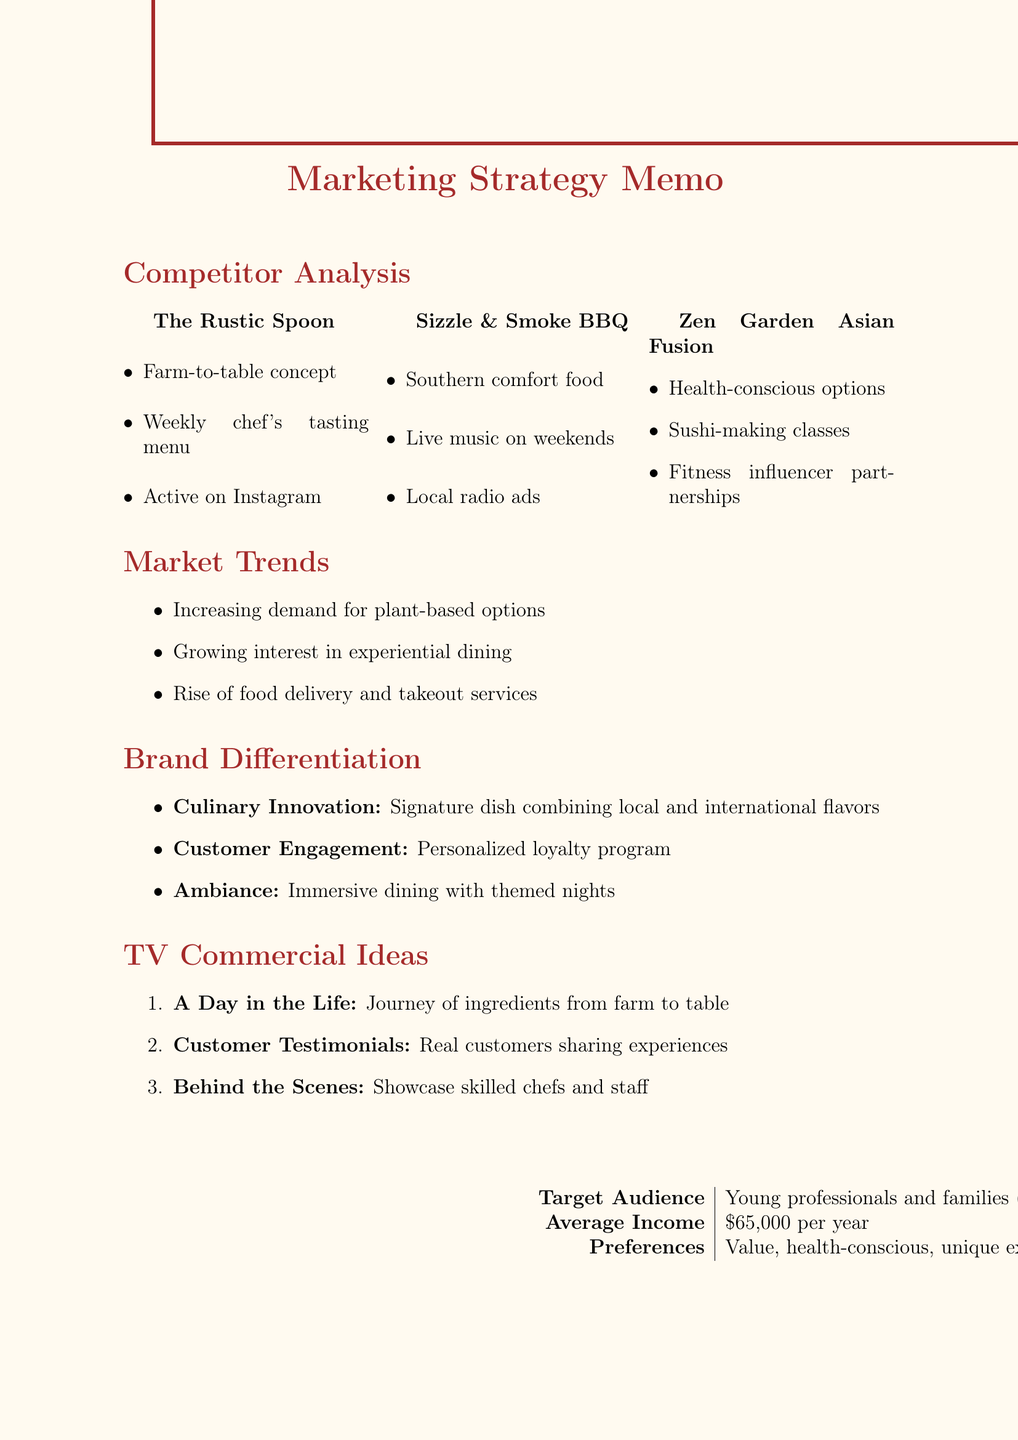What is the unique selling point of The Rustic Spoon? The unique selling point of The Rustic Spoon is highlighted in the document, which states it features a weekly chef's tasting menu showcasing seasonal specialties.
Answer: Weekly chef's tasting menu What marketing strategy does Sizzle & Smoke BBQ use? The marketing strategy of Sizzle & Smoke BBQ is described as Southern comfort food with a modern twist in the memo.
Answer: Southern comfort food with a modern twist Which restaurant offers interactive sushi-making classes? The document indicates that Zen Garden Asian Fusion offers interactive sushi-making classes for customers.
Answer: Zen Garden Asian Fusion What is one of the market trends mentioned? The document lists several market trends, one among them being increasing demand for plant-based menu options.
Answer: Increasing demand for plant-based menu options What aspect of brand differentiation focuses on customer loyalty? The aspect of brand differentiation that focuses on customer loyalty is described as implementing a loyalty program with personalized rewards based on dining preferences.
Answer: Customer Engagement How many TV commercial ideas are suggested? The memo provides three distinct TV commercial ideas to consider for marketing.
Answer: Three What demographic is the target audience? The target audience is specified in the document as young professionals and families aged 25-45.
Answer: Young professionals and families aged 25-45 What is the average income of the local demographic? The document provides the average income of the local demographic, indicating it is $65,000 per year.
Answer: $65,000 per year 